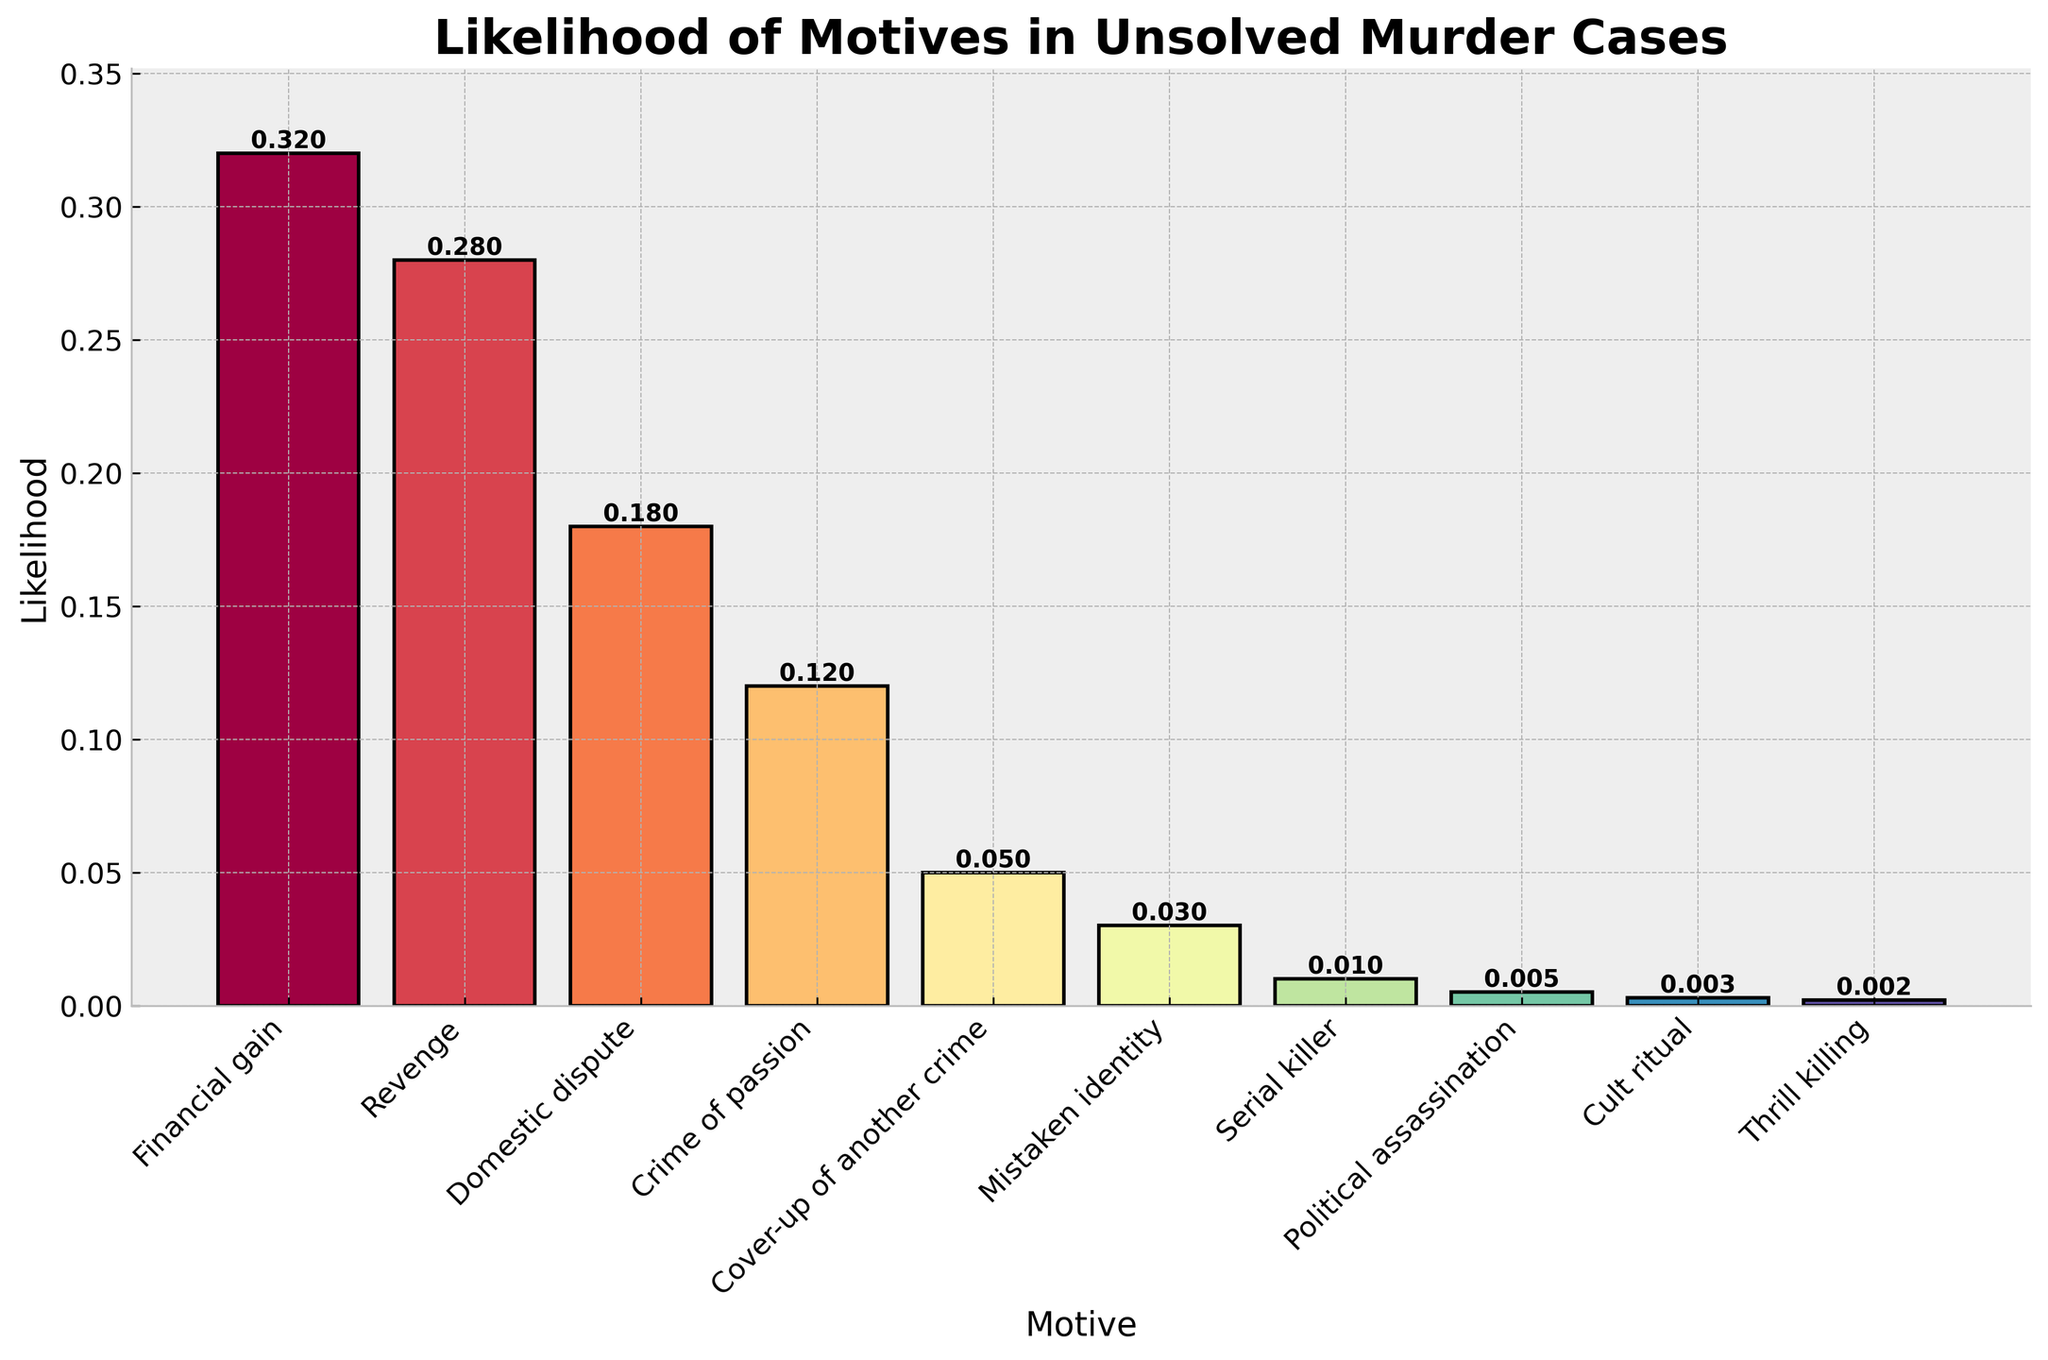What is the likelihood of a Financial gain motive? The chart shows the likelihood for each motive. Locate "Financial gain" and read its likelihood value from the bar.
Answer: 0.32 Which motive has the lowest likelihood? Locate the shortest bar in the chart and read the corresponding motive's name.
Answer: Thrill killing Is the likelihood of a Domestic dispute motive higher than Revenge? Compare the bars corresponding to "Domestic dispute" and "Revenge". "Revenge" is higher than "Domestic dispute".
Answer: No How much higher is the likelihood of Financial gain compared to Crime of passion? Find the difference in their respective likelihood values. The bar for "Financial gain" is 0.32 and "Crime of passion" is 0.12. Subtract 0.12 from 0.32.
Answer: 0.20 What is the total likelihood for all motives? Summing up all the likelihood values: 0.32 + 0.28 + 0.18 + 0.12 + 0.05 + 0.03 + 0.01 + 0.005 + 0.003 + 0.002 = 1.00
Answer: 1.00 Which motive appears to be the most likely based on height? Identify the tallest bar in the chart and read the corresponding motive's name.
Answer: Financial gain How much more likely is Revenge compared to Cover-up of another crime? Subtract the likelihood of "Cover-up of another crime" from "Revenge". For "Revenge" is 0.28 and "Cover-up of another crime" is 0.05.
Answer: 0.23 List the motives in descending order of likelihood. Rank the motives based on the height of their bars from tallest to shortest: Financial gain, Revenge, Domestic dispute, Crime of passion, Cover-up of another crime, Mistaken identity, Serial killer, Political assassination, Cult ritual, Thrill killing.
Answer: Financial gain, Revenge, Domestic dispute, Crime of passion, Cover-up of another crime, Mistaken identity, Serial killer, Political assassination, Cult ritual, Thrill killing What is the combined likelihood of Domestic dispute and Crime of passion? Add the likelihood values of "Domestic dispute" (0.18) and "Crime of passion" (0.12).
Answer: 0.30 Which motives have a likelihood greater than 0.2? Identify the bars higher than 0.2. They are "Financial gain" (0.32) and "Revenge" (0.28).
Answer: Financial gain, Revenge 